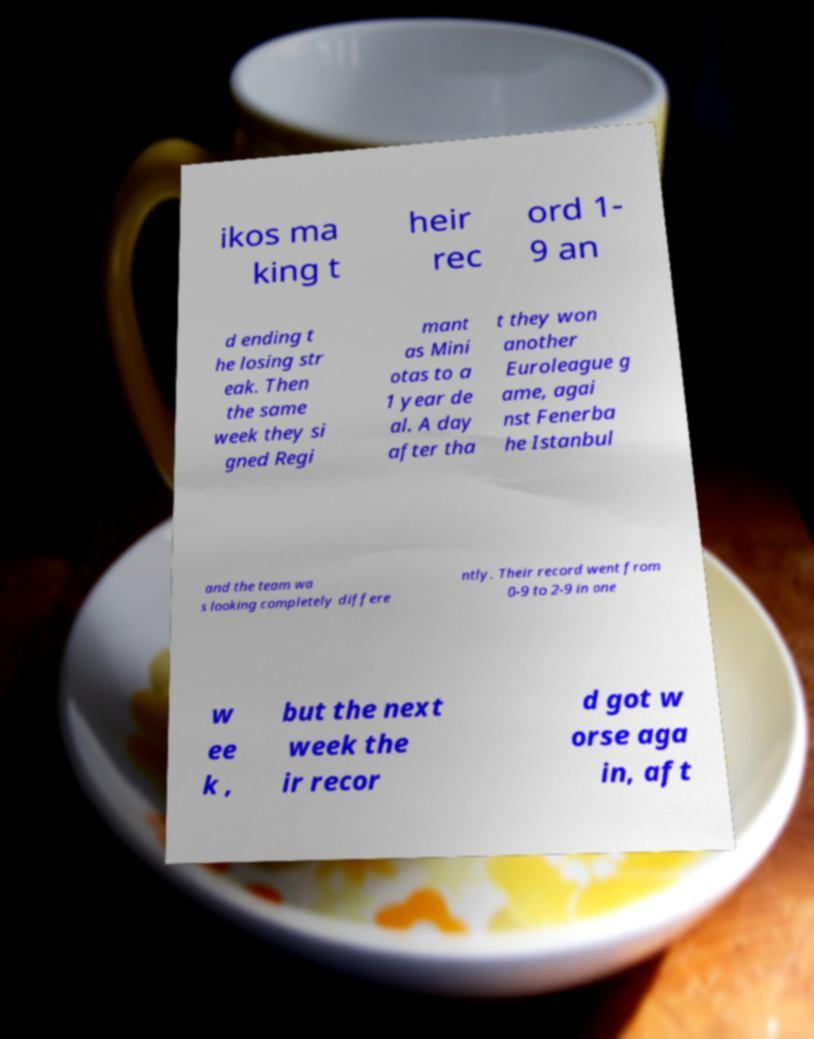For documentation purposes, I need the text within this image transcribed. Could you provide that? ikos ma king t heir rec ord 1- 9 an d ending t he losing str eak. Then the same week they si gned Regi mant as Mini otas to a 1 year de al. A day after tha t they won another Euroleague g ame, agai nst Fenerba he Istanbul and the team wa s looking completely differe ntly. Their record went from 0-9 to 2-9 in one w ee k , but the next week the ir recor d got w orse aga in, aft 